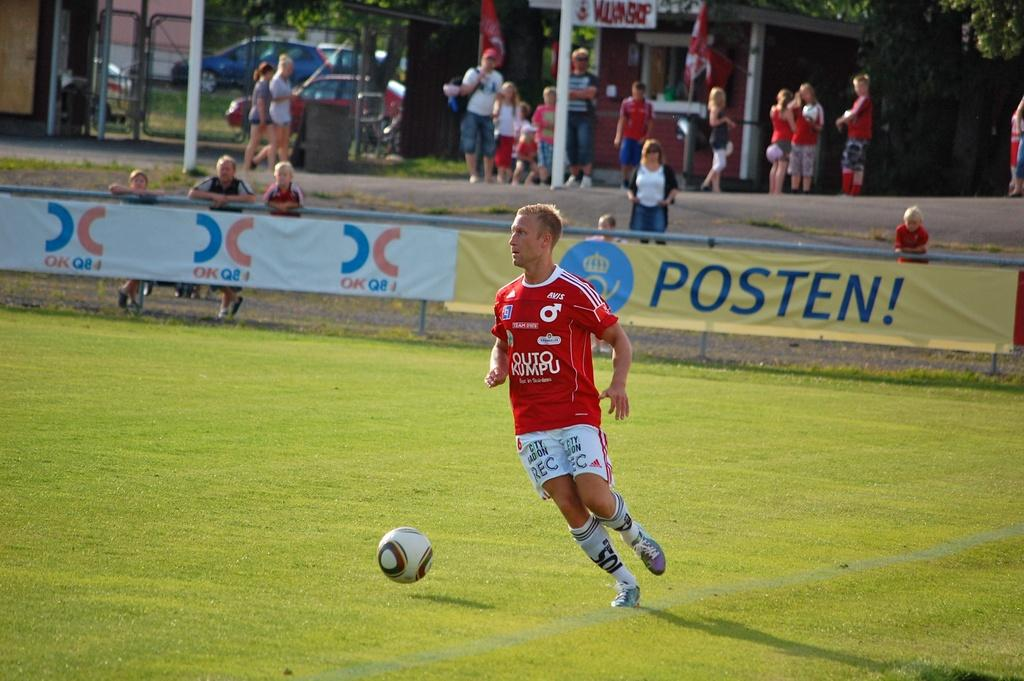Provide a one-sentence caption for the provided image. A blond man wearing a red Outo Kumpu jersey with a soccer ball on a green field with a sign saying Posten! behind him. 